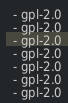Convert code to text. <code><loc_0><loc_0><loc_500><loc_500><_YAML_>  - gpl-2.0
  - gpl-2.0
  - gpl-2.0
  - gpl-2.0
  - gpl-2.0
  - gpl-2.0
  - gpl-2.0
</code> 